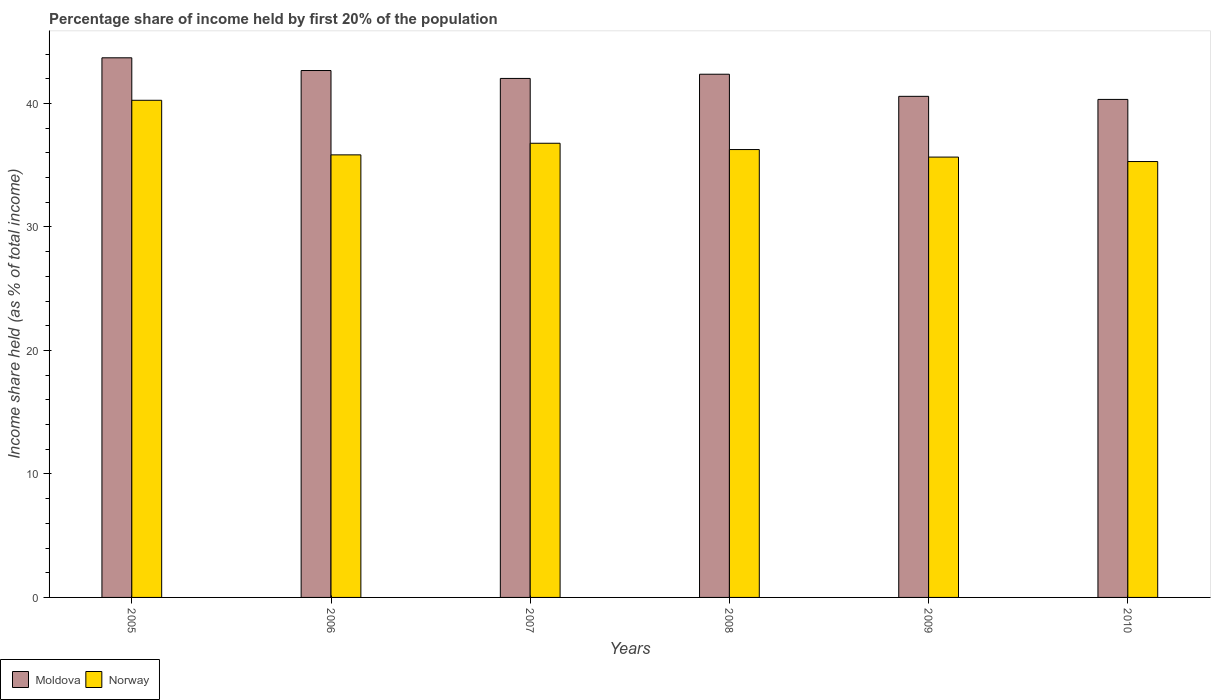How many different coloured bars are there?
Provide a short and direct response. 2. Are the number of bars on each tick of the X-axis equal?
Give a very brief answer. Yes. How many bars are there on the 4th tick from the right?
Your answer should be compact. 2. What is the label of the 5th group of bars from the left?
Offer a terse response. 2009. What is the share of income held by first 20% of the population in Moldova in 2008?
Keep it short and to the point. 42.37. Across all years, what is the maximum share of income held by first 20% of the population in Norway?
Offer a very short reply. 40.26. Across all years, what is the minimum share of income held by first 20% of the population in Moldova?
Provide a short and direct response. 40.33. In which year was the share of income held by first 20% of the population in Norway maximum?
Make the answer very short. 2005. In which year was the share of income held by first 20% of the population in Norway minimum?
Give a very brief answer. 2010. What is the total share of income held by first 20% of the population in Moldova in the graph?
Offer a terse response. 251.68. What is the difference between the share of income held by first 20% of the population in Moldova in 2006 and that in 2007?
Provide a succinct answer. 0.64. What is the difference between the share of income held by first 20% of the population in Moldova in 2007 and the share of income held by first 20% of the population in Norway in 2006?
Your answer should be compact. 6.19. What is the average share of income held by first 20% of the population in Norway per year?
Your response must be concise. 36.69. In the year 2005, what is the difference between the share of income held by first 20% of the population in Moldova and share of income held by first 20% of the population in Norway?
Your response must be concise. 3.44. What is the ratio of the share of income held by first 20% of the population in Moldova in 2006 to that in 2007?
Offer a terse response. 1.02. Is the share of income held by first 20% of the population in Moldova in 2006 less than that in 2008?
Your response must be concise. No. Is the difference between the share of income held by first 20% of the population in Moldova in 2008 and 2010 greater than the difference between the share of income held by first 20% of the population in Norway in 2008 and 2010?
Keep it short and to the point. Yes. What is the difference between the highest and the second highest share of income held by first 20% of the population in Norway?
Your answer should be very brief. 3.48. What is the difference between the highest and the lowest share of income held by first 20% of the population in Moldova?
Give a very brief answer. 3.37. In how many years, is the share of income held by first 20% of the population in Norway greater than the average share of income held by first 20% of the population in Norway taken over all years?
Make the answer very short. 2. What does the 2nd bar from the left in 2006 represents?
Ensure brevity in your answer.  Norway. What does the 2nd bar from the right in 2008 represents?
Keep it short and to the point. Moldova. How many bars are there?
Your answer should be compact. 12. What is the difference between two consecutive major ticks on the Y-axis?
Your response must be concise. 10. Does the graph contain grids?
Keep it short and to the point. No. Where does the legend appear in the graph?
Your response must be concise. Bottom left. How are the legend labels stacked?
Provide a short and direct response. Horizontal. What is the title of the graph?
Offer a terse response. Percentage share of income held by first 20% of the population. What is the label or title of the Y-axis?
Provide a short and direct response. Income share held (as % of total income). What is the Income share held (as % of total income) in Moldova in 2005?
Provide a short and direct response. 43.7. What is the Income share held (as % of total income) in Norway in 2005?
Offer a terse response. 40.26. What is the Income share held (as % of total income) of Moldova in 2006?
Ensure brevity in your answer.  42.67. What is the Income share held (as % of total income) in Norway in 2006?
Offer a very short reply. 35.84. What is the Income share held (as % of total income) in Moldova in 2007?
Your answer should be compact. 42.03. What is the Income share held (as % of total income) in Norway in 2007?
Ensure brevity in your answer.  36.78. What is the Income share held (as % of total income) of Moldova in 2008?
Keep it short and to the point. 42.37. What is the Income share held (as % of total income) of Norway in 2008?
Give a very brief answer. 36.27. What is the Income share held (as % of total income) in Moldova in 2009?
Provide a short and direct response. 40.58. What is the Income share held (as % of total income) in Norway in 2009?
Offer a terse response. 35.66. What is the Income share held (as % of total income) in Moldova in 2010?
Provide a succinct answer. 40.33. What is the Income share held (as % of total income) in Norway in 2010?
Your answer should be very brief. 35.3. Across all years, what is the maximum Income share held (as % of total income) in Moldova?
Give a very brief answer. 43.7. Across all years, what is the maximum Income share held (as % of total income) of Norway?
Give a very brief answer. 40.26. Across all years, what is the minimum Income share held (as % of total income) in Moldova?
Your answer should be very brief. 40.33. Across all years, what is the minimum Income share held (as % of total income) of Norway?
Your answer should be very brief. 35.3. What is the total Income share held (as % of total income) in Moldova in the graph?
Keep it short and to the point. 251.68. What is the total Income share held (as % of total income) in Norway in the graph?
Your response must be concise. 220.11. What is the difference between the Income share held (as % of total income) in Moldova in 2005 and that in 2006?
Your answer should be very brief. 1.03. What is the difference between the Income share held (as % of total income) of Norway in 2005 and that in 2006?
Provide a succinct answer. 4.42. What is the difference between the Income share held (as % of total income) of Moldova in 2005 and that in 2007?
Your answer should be compact. 1.67. What is the difference between the Income share held (as % of total income) in Norway in 2005 and that in 2007?
Provide a succinct answer. 3.48. What is the difference between the Income share held (as % of total income) of Moldova in 2005 and that in 2008?
Give a very brief answer. 1.33. What is the difference between the Income share held (as % of total income) of Norway in 2005 and that in 2008?
Your answer should be very brief. 3.99. What is the difference between the Income share held (as % of total income) of Moldova in 2005 and that in 2009?
Your response must be concise. 3.12. What is the difference between the Income share held (as % of total income) of Norway in 2005 and that in 2009?
Offer a terse response. 4.6. What is the difference between the Income share held (as % of total income) in Moldova in 2005 and that in 2010?
Keep it short and to the point. 3.37. What is the difference between the Income share held (as % of total income) of Norway in 2005 and that in 2010?
Your answer should be compact. 4.96. What is the difference between the Income share held (as % of total income) in Moldova in 2006 and that in 2007?
Offer a very short reply. 0.64. What is the difference between the Income share held (as % of total income) in Norway in 2006 and that in 2007?
Ensure brevity in your answer.  -0.94. What is the difference between the Income share held (as % of total income) of Norway in 2006 and that in 2008?
Ensure brevity in your answer.  -0.43. What is the difference between the Income share held (as % of total income) of Moldova in 2006 and that in 2009?
Your response must be concise. 2.09. What is the difference between the Income share held (as % of total income) in Norway in 2006 and that in 2009?
Provide a succinct answer. 0.18. What is the difference between the Income share held (as % of total income) in Moldova in 2006 and that in 2010?
Make the answer very short. 2.34. What is the difference between the Income share held (as % of total income) in Norway in 2006 and that in 2010?
Your answer should be compact. 0.54. What is the difference between the Income share held (as % of total income) of Moldova in 2007 and that in 2008?
Provide a short and direct response. -0.34. What is the difference between the Income share held (as % of total income) of Norway in 2007 and that in 2008?
Provide a short and direct response. 0.51. What is the difference between the Income share held (as % of total income) of Moldova in 2007 and that in 2009?
Make the answer very short. 1.45. What is the difference between the Income share held (as % of total income) in Norway in 2007 and that in 2009?
Give a very brief answer. 1.12. What is the difference between the Income share held (as % of total income) in Norway in 2007 and that in 2010?
Your answer should be compact. 1.48. What is the difference between the Income share held (as % of total income) in Moldova in 2008 and that in 2009?
Your answer should be very brief. 1.79. What is the difference between the Income share held (as % of total income) of Norway in 2008 and that in 2009?
Provide a succinct answer. 0.61. What is the difference between the Income share held (as % of total income) in Moldova in 2008 and that in 2010?
Give a very brief answer. 2.04. What is the difference between the Income share held (as % of total income) of Norway in 2008 and that in 2010?
Give a very brief answer. 0.97. What is the difference between the Income share held (as % of total income) of Moldova in 2009 and that in 2010?
Give a very brief answer. 0.25. What is the difference between the Income share held (as % of total income) of Norway in 2009 and that in 2010?
Give a very brief answer. 0.36. What is the difference between the Income share held (as % of total income) in Moldova in 2005 and the Income share held (as % of total income) in Norway in 2006?
Offer a very short reply. 7.86. What is the difference between the Income share held (as % of total income) in Moldova in 2005 and the Income share held (as % of total income) in Norway in 2007?
Your answer should be compact. 6.92. What is the difference between the Income share held (as % of total income) of Moldova in 2005 and the Income share held (as % of total income) of Norway in 2008?
Offer a very short reply. 7.43. What is the difference between the Income share held (as % of total income) of Moldova in 2005 and the Income share held (as % of total income) of Norway in 2009?
Give a very brief answer. 8.04. What is the difference between the Income share held (as % of total income) of Moldova in 2005 and the Income share held (as % of total income) of Norway in 2010?
Offer a terse response. 8.4. What is the difference between the Income share held (as % of total income) in Moldova in 2006 and the Income share held (as % of total income) in Norway in 2007?
Your response must be concise. 5.89. What is the difference between the Income share held (as % of total income) of Moldova in 2006 and the Income share held (as % of total income) of Norway in 2009?
Your answer should be compact. 7.01. What is the difference between the Income share held (as % of total income) in Moldova in 2006 and the Income share held (as % of total income) in Norway in 2010?
Keep it short and to the point. 7.37. What is the difference between the Income share held (as % of total income) in Moldova in 2007 and the Income share held (as % of total income) in Norway in 2008?
Offer a terse response. 5.76. What is the difference between the Income share held (as % of total income) of Moldova in 2007 and the Income share held (as % of total income) of Norway in 2009?
Keep it short and to the point. 6.37. What is the difference between the Income share held (as % of total income) in Moldova in 2007 and the Income share held (as % of total income) in Norway in 2010?
Provide a succinct answer. 6.73. What is the difference between the Income share held (as % of total income) of Moldova in 2008 and the Income share held (as % of total income) of Norway in 2009?
Offer a very short reply. 6.71. What is the difference between the Income share held (as % of total income) of Moldova in 2008 and the Income share held (as % of total income) of Norway in 2010?
Offer a terse response. 7.07. What is the difference between the Income share held (as % of total income) of Moldova in 2009 and the Income share held (as % of total income) of Norway in 2010?
Keep it short and to the point. 5.28. What is the average Income share held (as % of total income) of Moldova per year?
Your answer should be very brief. 41.95. What is the average Income share held (as % of total income) in Norway per year?
Offer a very short reply. 36.69. In the year 2005, what is the difference between the Income share held (as % of total income) of Moldova and Income share held (as % of total income) of Norway?
Give a very brief answer. 3.44. In the year 2006, what is the difference between the Income share held (as % of total income) in Moldova and Income share held (as % of total income) in Norway?
Offer a very short reply. 6.83. In the year 2007, what is the difference between the Income share held (as % of total income) of Moldova and Income share held (as % of total income) of Norway?
Ensure brevity in your answer.  5.25. In the year 2009, what is the difference between the Income share held (as % of total income) of Moldova and Income share held (as % of total income) of Norway?
Provide a short and direct response. 4.92. In the year 2010, what is the difference between the Income share held (as % of total income) of Moldova and Income share held (as % of total income) of Norway?
Your answer should be very brief. 5.03. What is the ratio of the Income share held (as % of total income) of Moldova in 2005 to that in 2006?
Give a very brief answer. 1.02. What is the ratio of the Income share held (as % of total income) in Norway in 2005 to that in 2006?
Offer a very short reply. 1.12. What is the ratio of the Income share held (as % of total income) in Moldova in 2005 to that in 2007?
Your answer should be compact. 1.04. What is the ratio of the Income share held (as % of total income) of Norway in 2005 to that in 2007?
Provide a succinct answer. 1.09. What is the ratio of the Income share held (as % of total income) in Moldova in 2005 to that in 2008?
Provide a short and direct response. 1.03. What is the ratio of the Income share held (as % of total income) in Norway in 2005 to that in 2008?
Keep it short and to the point. 1.11. What is the ratio of the Income share held (as % of total income) in Moldova in 2005 to that in 2009?
Your response must be concise. 1.08. What is the ratio of the Income share held (as % of total income) of Norway in 2005 to that in 2009?
Your response must be concise. 1.13. What is the ratio of the Income share held (as % of total income) of Moldova in 2005 to that in 2010?
Offer a terse response. 1.08. What is the ratio of the Income share held (as % of total income) of Norway in 2005 to that in 2010?
Ensure brevity in your answer.  1.14. What is the ratio of the Income share held (as % of total income) of Moldova in 2006 to that in 2007?
Offer a very short reply. 1.02. What is the ratio of the Income share held (as % of total income) in Norway in 2006 to that in 2007?
Your answer should be very brief. 0.97. What is the ratio of the Income share held (as % of total income) in Moldova in 2006 to that in 2008?
Your answer should be very brief. 1.01. What is the ratio of the Income share held (as % of total income) in Moldova in 2006 to that in 2009?
Your response must be concise. 1.05. What is the ratio of the Income share held (as % of total income) of Norway in 2006 to that in 2009?
Ensure brevity in your answer.  1. What is the ratio of the Income share held (as % of total income) of Moldova in 2006 to that in 2010?
Your answer should be very brief. 1.06. What is the ratio of the Income share held (as % of total income) in Norway in 2006 to that in 2010?
Offer a very short reply. 1.02. What is the ratio of the Income share held (as % of total income) of Norway in 2007 to that in 2008?
Ensure brevity in your answer.  1.01. What is the ratio of the Income share held (as % of total income) of Moldova in 2007 to that in 2009?
Provide a succinct answer. 1.04. What is the ratio of the Income share held (as % of total income) of Norway in 2007 to that in 2009?
Provide a succinct answer. 1.03. What is the ratio of the Income share held (as % of total income) of Moldova in 2007 to that in 2010?
Provide a succinct answer. 1.04. What is the ratio of the Income share held (as % of total income) of Norway in 2007 to that in 2010?
Your answer should be compact. 1.04. What is the ratio of the Income share held (as % of total income) in Moldova in 2008 to that in 2009?
Your answer should be very brief. 1.04. What is the ratio of the Income share held (as % of total income) in Norway in 2008 to that in 2009?
Make the answer very short. 1.02. What is the ratio of the Income share held (as % of total income) of Moldova in 2008 to that in 2010?
Offer a very short reply. 1.05. What is the ratio of the Income share held (as % of total income) in Norway in 2008 to that in 2010?
Offer a terse response. 1.03. What is the ratio of the Income share held (as % of total income) in Norway in 2009 to that in 2010?
Your answer should be compact. 1.01. What is the difference between the highest and the second highest Income share held (as % of total income) in Moldova?
Provide a short and direct response. 1.03. What is the difference between the highest and the second highest Income share held (as % of total income) in Norway?
Make the answer very short. 3.48. What is the difference between the highest and the lowest Income share held (as % of total income) in Moldova?
Ensure brevity in your answer.  3.37. What is the difference between the highest and the lowest Income share held (as % of total income) in Norway?
Offer a terse response. 4.96. 